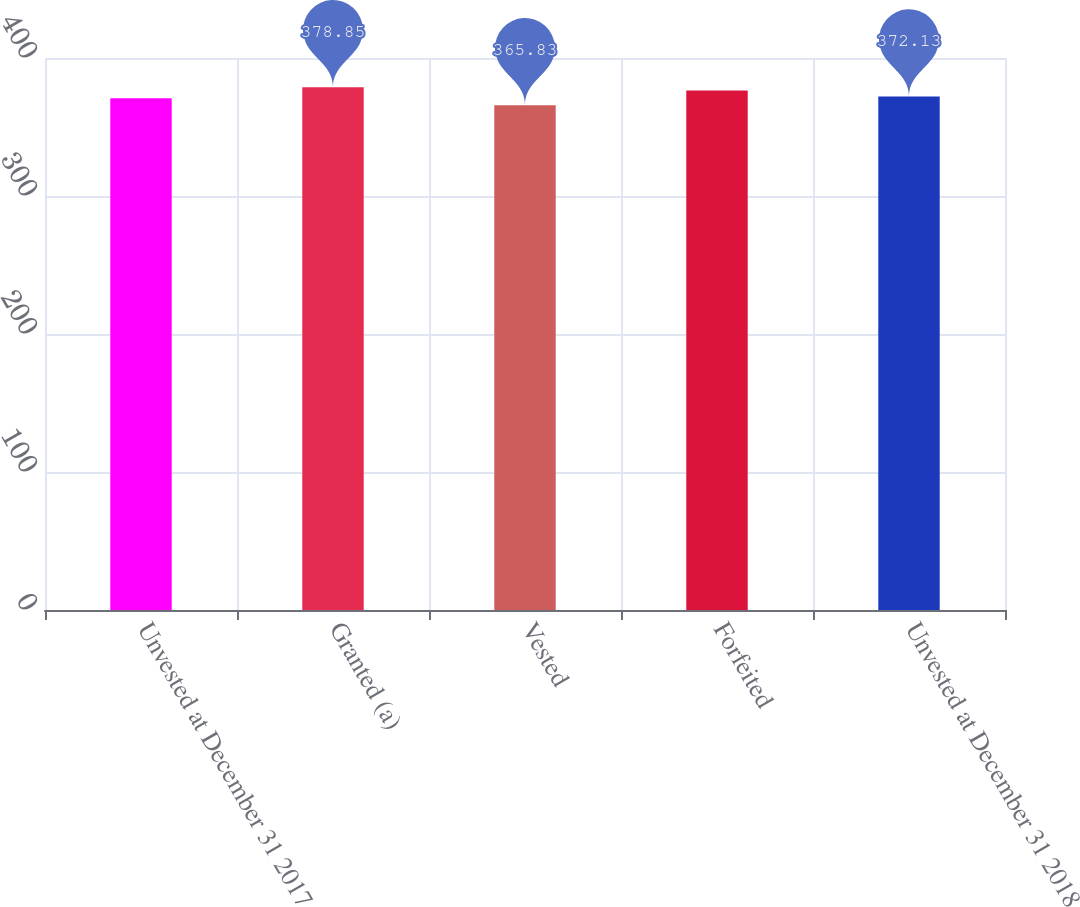Convert chart. <chart><loc_0><loc_0><loc_500><loc_500><bar_chart><fcel>Unvested at December 31 2017<fcel>Granted (a)<fcel>Vested<fcel>Forfeited<fcel>Unvested at December 31 2018<nl><fcel>370.83<fcel>378.85<fcel>365.83<fcel>376.51<fcel>372.13<nl></chart> 